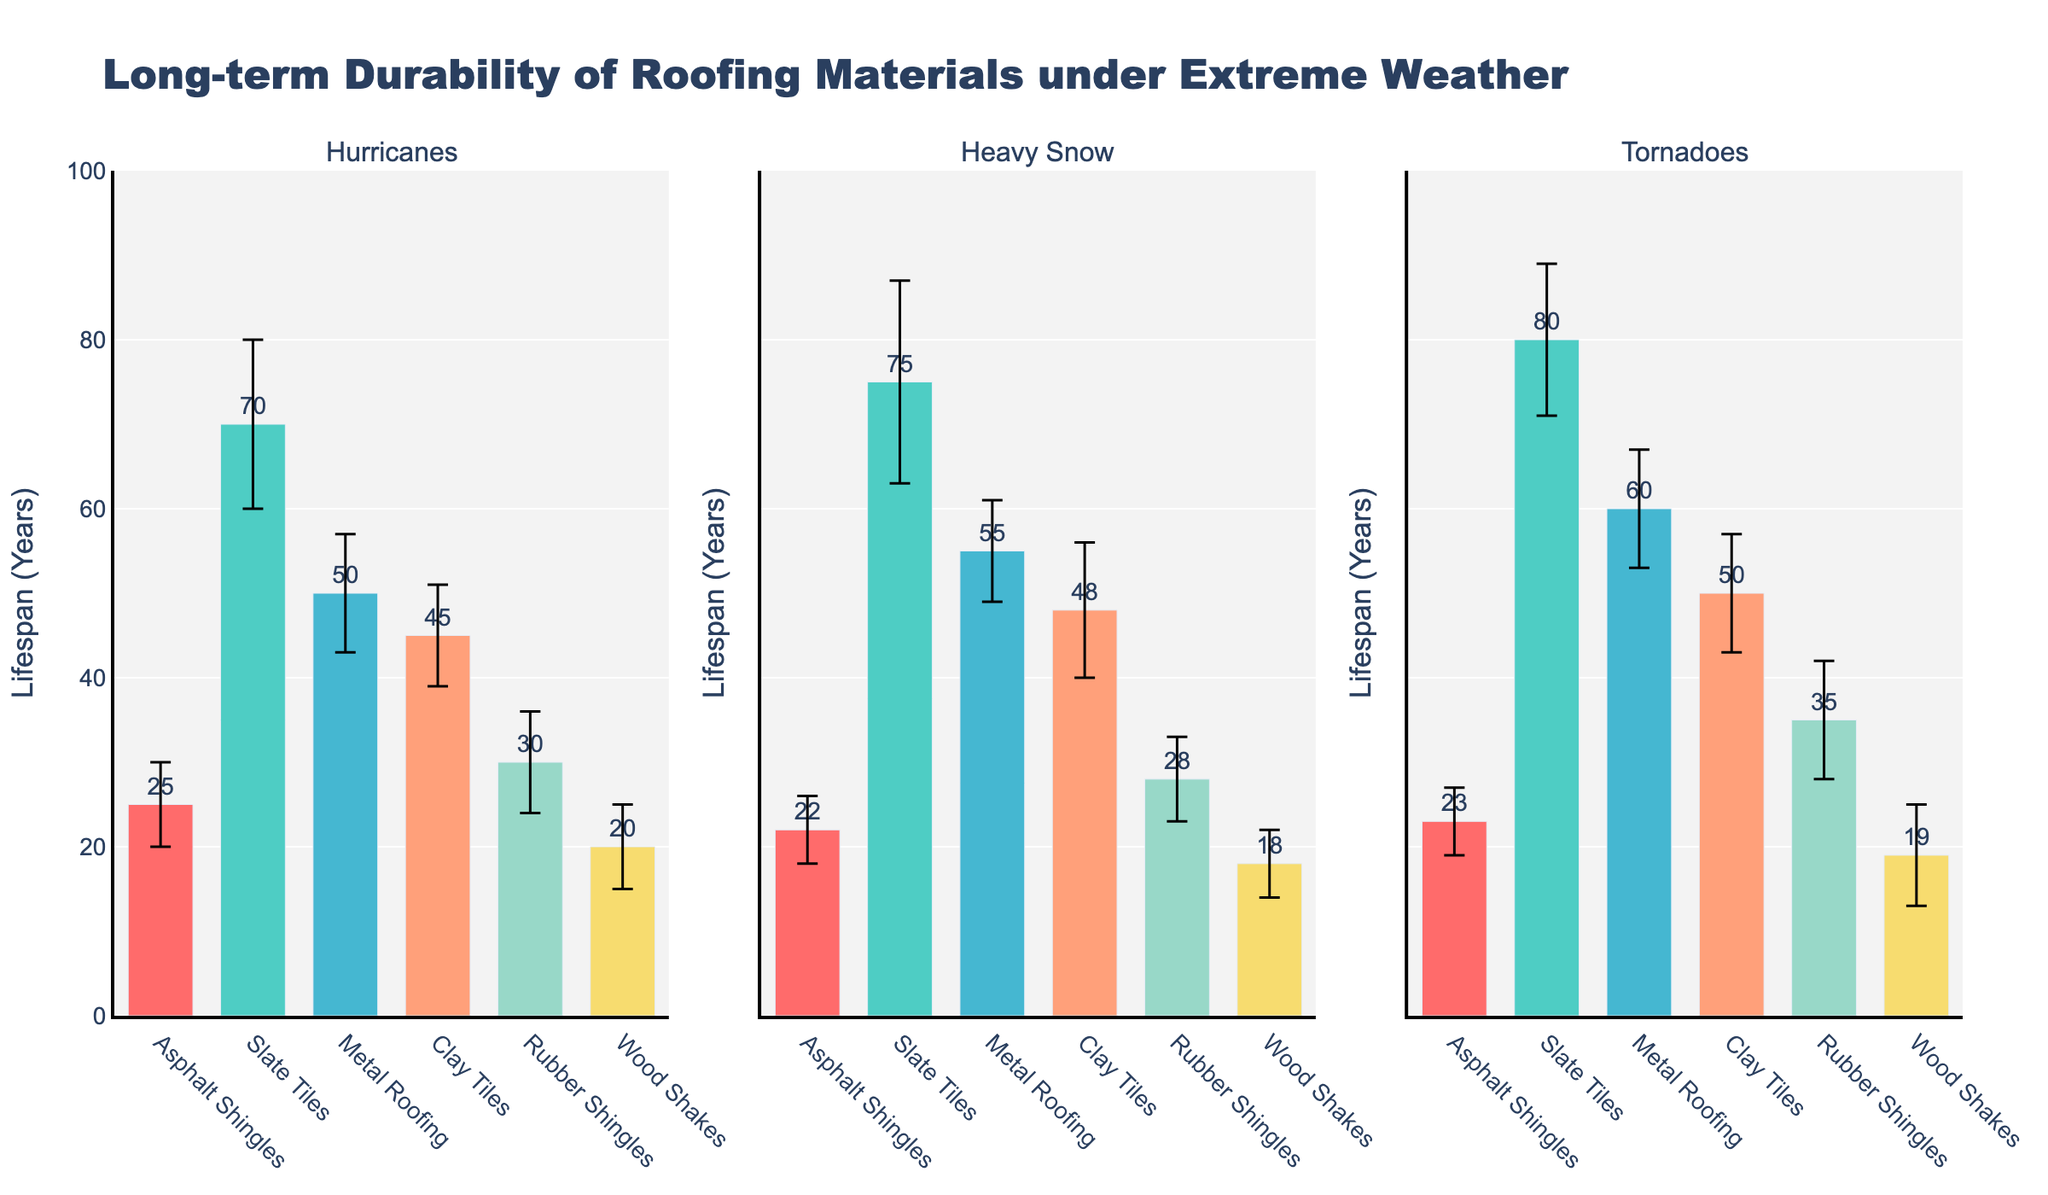Which roofing material has the highest mean lifespan under hurricanes? To answer this, look at the bar height in the "Hurricanes" subplot, and identify the tallest bar, which represents the highest mean lifespan. Slate Tiles have the highest mean lifespan under hurricanes.
Answer: Slate Tiles What is the mean lifespan difference between Metal Roofing and Clay Tiles under tornadoes? First, find the mean lifespan of Metal Roofing and Clay Tiles under tornadoes by looking at their respective bars in the "Tornadoes" subplot. Metal Roofing has a lifespan of 60 years, and Clay Tiles have 50 years. The difference is 60 - 50.
Answer: 10 years Which roofing material shows the greatest variability in lifespan under heavy snow, and how do you know? Variability is indicated by the length of the error bars. In the "Heavy Snow" subplot, find the material with the longest error bar. Slate Tiles show the greatest variability with the longest error bar, indicating a standard deviation of 12 years.
Answer: Slate Tiles Of the residential roofing materials, which one is the shortest-lived under heavy snow, and what is its mean lifespan? Focus on residential materials in the "Heavy Snow" subplot. Identify the shortest bar among residential materials, which is Wood Shakes. The mean lifespan is displayed and is 18 years.
Answer: Wood Shakes, 18 years How does the mean lifespan of Rubber Shingles compare across all types of extreme weather? Look at the bars for Rubber Shingles across the "Hurricanes," "Heavy Snow," and "Tornadoes" subplots. The mean lifespans are 30, 28, and 35 years, respectively. Compare these values to see that under tornadoes, Rubber Shingles have the highest mean lifespan.
Answer: Highest under tornadoes What's the overall trend of the mean lifespan for residential roofing materials under heavy snow? Examine the "Heavy Snow" subplot and note the mean lifespan heights for all residential materials: Asphalt Shingles (22), Slate Tiles (75), Clay Tiles (48), and Wood Shakes (18). The trend shows significant variability, with Slate Tiles having the longest lifespan and Wood Shakes the shortest.
Answer: Variable, with Slate Tiles longest Which roofing materials have overlapping error bars under hurricanes, indicating potentially similar lifespans? In the "Hurricanes" subplot, find bars where the error bars overlap. Asphalt Shingles (25 ± 5), Clay Tiles (45 ± 6), and Rubber Shingles (30 ± 6) show some overlapping ranges. This overlap suggests their lifespans might not be significantly different from each other.
Answer: Asphalt Shingles, Clay Tiles, Rubber Shingles 